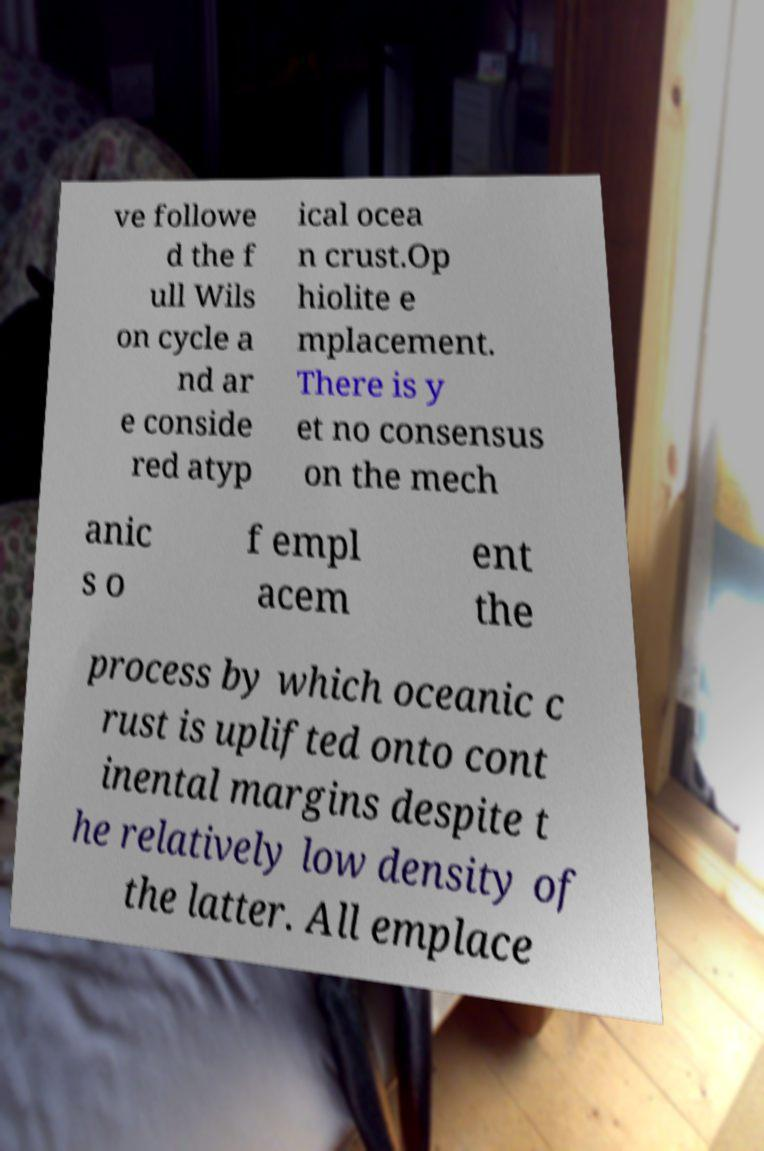I need the written content from this picture converted into text. Can you do that? ve followe d the f ull Wils on cycle a nd ar e conside red atyp ical ocea n crust.Op hiolite e mplacement. There is y et no consensus on the mech anic s o f empl acem ent the process by which oceanic c rust is uplifted onto cont inental margins despite t he relatively low density of the latter. All emplace 